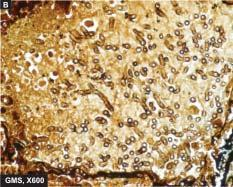what are best identified with a special stain for fungi, gomory 's methenamine silver gms?
Answer the question using a single word or phrase. Apergillus flavus 